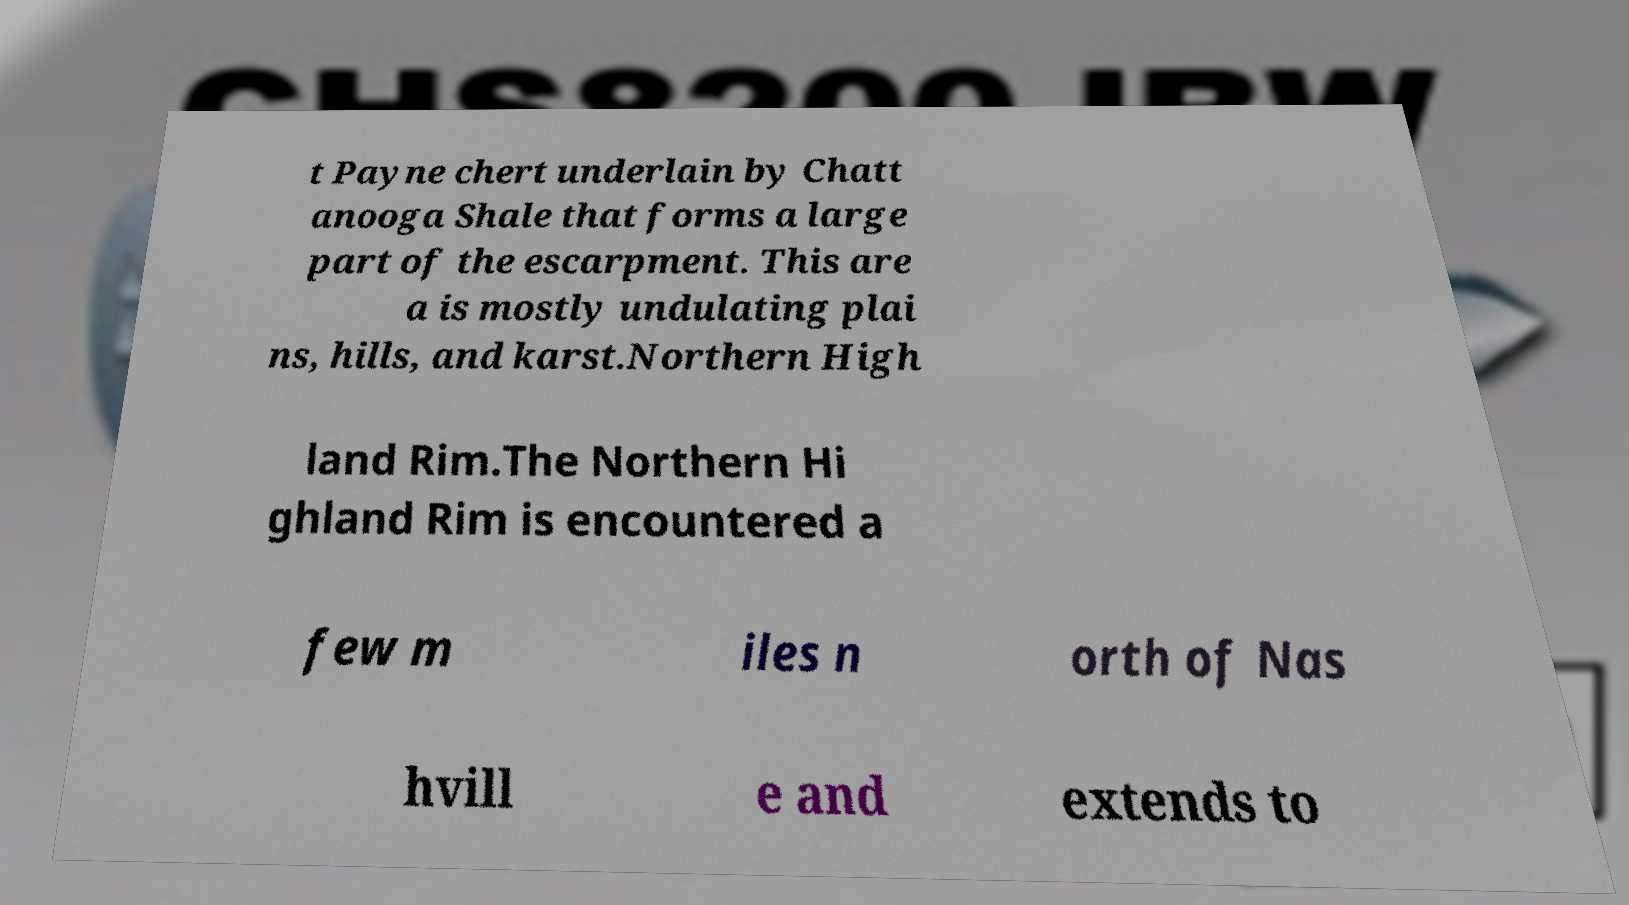For documentation purposes, I need the text within this image transcribed. Could you provide that? t Payne chert underlain by Chatt anooga Shale that forms a large part of the escarpment. This are a is mostly undulating plai ns, hills, and karst.Northern High land Rim.The Northern Hi ghland Rim is encountered a few m iles n orth of Nas hvill e and extends to 